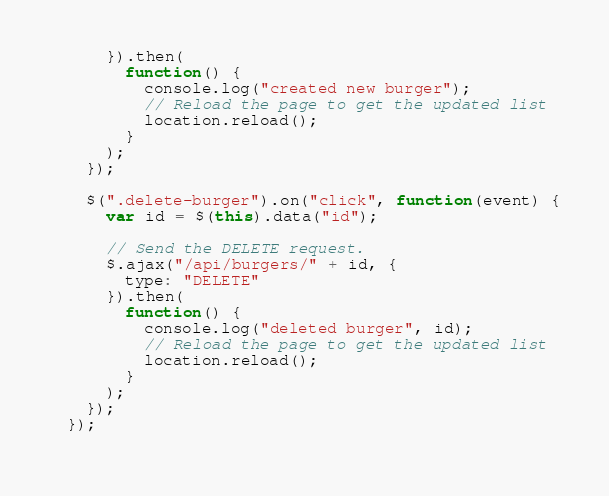Convert code to text. <code><loc_0><loc_0><loc_500><loc_500><_JavaScript_>      }).then(
        function() {
          console.log("created new burger");
          // Reload the page to get the updated list
          location.reload();
        }
      );
    });
  
    $(".delete-burger").on("click", function(event) {
      var id = $(this).data("id");
  
      // Send the DELETE request.
      $.ajax("/api/burgers/" + id, {
        type: "DELETE"
      }).then(
        function() {
          console.log("deleted burger", id);
          // Reload the page to get the updated list
          location.reload();
        }
      );
    });
  });
  </code> 